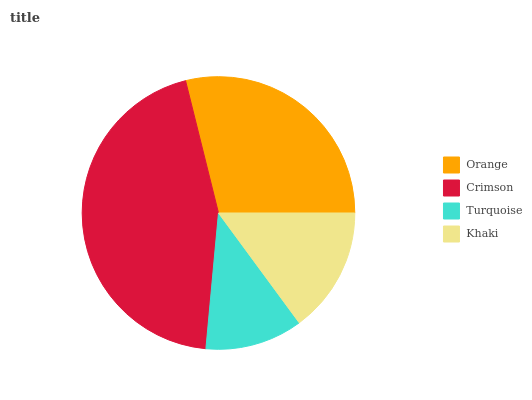Is Turquoise the minimum?
Answer yes or no. Yes. Is Crimson the maximum?
Answer yes or no. Yes. Is Crimson the minimum?
Answer yes or no. No. Is Turquoise the maximum?
Answer yes or no. No. Is Crimson greater than Turquoise?
Answer yes or no. Yes. Is Turquoise less than Crimson?
Answer yes or no. Yes. Is Turquoise greater than Crimson?
Answer yes or no. No. Is Crimson less than Turquoise?
Answer yes or no. No. Is Orange the high median?
Answer yes or no. Yes. Is Khaki the low median?
Answer yes or no. Yes. Is Turquoise the high median?
Answer yes or no. No. Is Orange the low median?
Answer yes or no. No. 